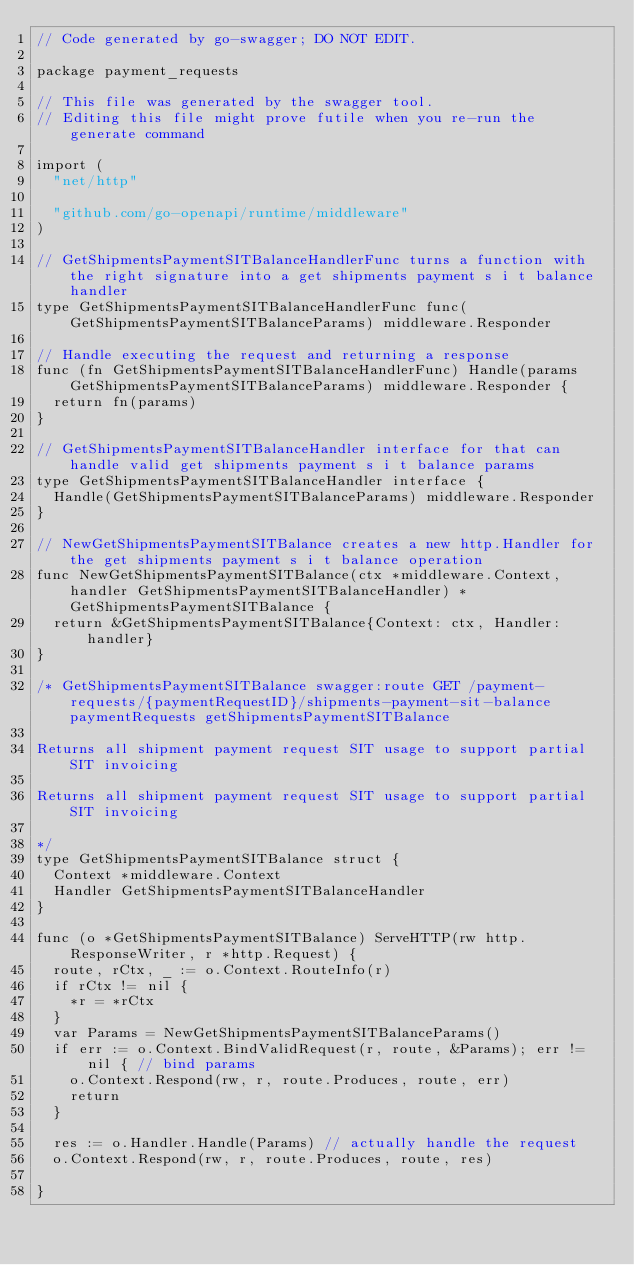Convert code to text. <code><loc_0><loc_0><loc_500><loc_500><_Go_>// Code generated by go-swagger; DO NOT EDIT.

package payment_requests

// This file was generated by the swagger tool.
// Editing this file might prove futile when you re-run the generate command

import (
	"net/http"

	"github.com/go-openapi/runtime/middleware"
)

// GetShipmentsPaymentSITBalanceHandlerFunc turns a function with the right signature into a get shipments payment s i t balance handler
type GetShipmentsPaymentSITBalanceHandlerFunc func(GetShipmentsPaymentSITBalanceParams) middleware.Responder

// Handle executing the request and returning a response
func (fn GetShipmentsPaymentSITBalanceHandlerFunc) Handle(params GetShipmentsPaymentSITBalanceParams) middleware.Responder {
	return fn(params)
}

// GetShipmentsPaymentSITBalanceHandler interface for that can handle valid get shipments payment s i t balance params
type GetShipmentsPaymentSITBalanceHandler interface {
	Handle(GetShipmentsPaymentSITBalanceParams) middleware.Responder
}

// NewGetShipmentsPaymentSITBalance creates a new http.Handler for the get shipments payment s i t balance operation
func NewGetShipmentsPaymentSITBalance(ctx *middleware.Context, handler GetShipmentsPaymentSITBalanceHandler) *GetShipmentsPaymentSITBalance {
	return &GetShipmentsPaymentSITBalance{Context: ctx, Handler: handler}
}

/* GetShipmentsPaymentSITBalance swagger:route GET /payment-requests/{paymentRequestID}/shipments-payment-sit-balance paymentRequests getShipmentsPaymentSITBalance

Returns all shipment payment request SIT usage to support partial SIT invoicing

Returns all shipment payment request SIT usage to support partial SIT invoicing

*/
type GetShipmentsPaymentSITBalance struct {
	Context *middleware.Context
	Handler GetShipmentsPaymentSITBalanceHandler
}

func (o *GetShipmentsPaymentSITBalance) ServeHTTP(rw http.ResponseWriter, r *http.Request) {
	route, rCtx, _ := o.Context.RouteInfo(r)
	if rCtx != nil {
		*r = *rCtx
	}
	var Params = NewGetShipmentsPaymentSITBalanceParams()
	if err := o.Context.BindValidRequest(r, route, &Params); err != nil { // bind params
		o.Context.Respond(rw, r, route.Produces, route, err)
		return
	}

	res := o.Handler.Handle(Params) // actually handle the request
	o.Context.Respond(rw, r, route.Produces, route, res)

}
</code> 